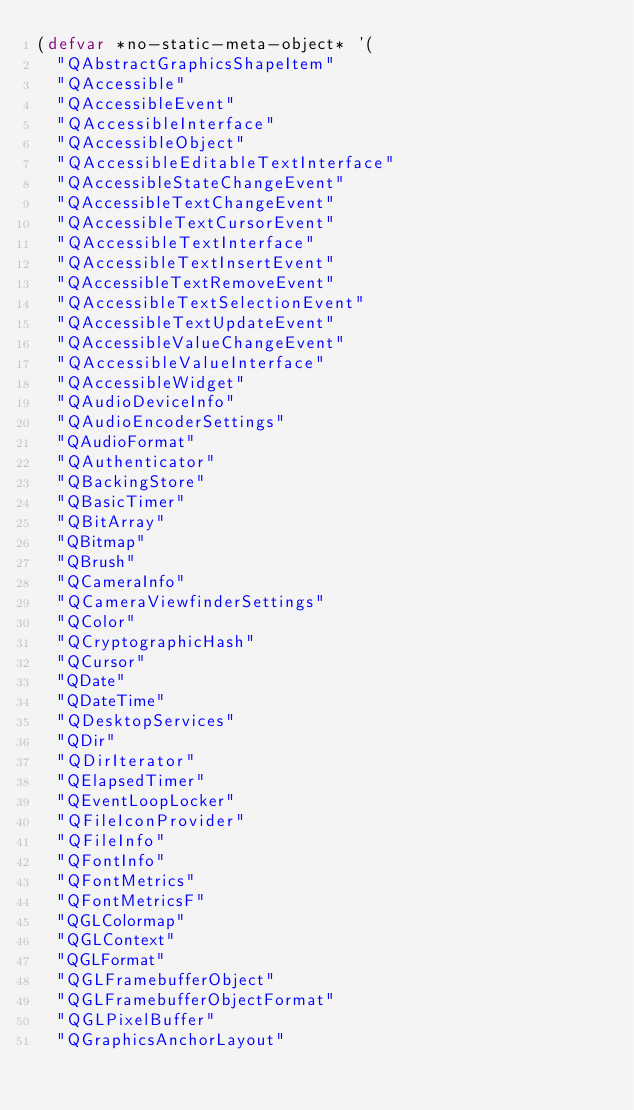<code> <loc_0><loc_0><loc_500><loc_500><_Lisp_>(defvar *no-static-meta-object* '(
  "QAbstractGraphicsShapeItem" 
  "QAccessible" 
  "QAccessibleEvent" 
  "QAccessibleInterface" 
  "QAccessibleObject"
  "QAccessibleEditableTextInterface"
  "QAccessibleStateChangeEvent"
  "QAccessibleTextChangeEvent"
  "QAccessibleTextCursorEvent"
  "QAccessibleTextInterface"
  "QAccessibleTextInsertEvent"
  "QAccessibleTextRemoveEvent"
  "QAccessibleTextSelectionEvent"
  "QAccessibleTextUpdateEvent"
  "QAccessibleValueChangeEvent"
  "QAccessibleValueInterface"
  "QAccessibleWidget"
  "QAudioDeviceInfo"
  "QAudioEncoderSettings"
  "QAudioFormat"
  "QAuthenticator"
  "QBackingStore"
  "QBasicTimer" 
  "QBitArray" 
  "QBitmap" 
  "QBrush" 
  "QCameraInfo"
  "QCameraViewfinderSettings"
  "QColor" 
  "QCryptographicHash" 
  "QCursor" 
  "QDate" 
  "QDateTime" 
  "QDesktopServices" 
  "QDir" 
  "QDirIterator" 
  "QElapsedTimer"
  "QEventLoopLocker"
  "QFileIconProvider" 
  "QFileInfo" 
  "QFontInfo" 
  "QFontMetrics" 
  "QFontMetricsF" 
  "QGLColormap" 
  "QGLContext" 
  "QGLFormat" 
  "QGLFramebufferObject" 
  "QGLFramebufferObjectFormat" 
  "QGLPixelBuffer" 
  "QGraphicsAnchorLayout" </code> 